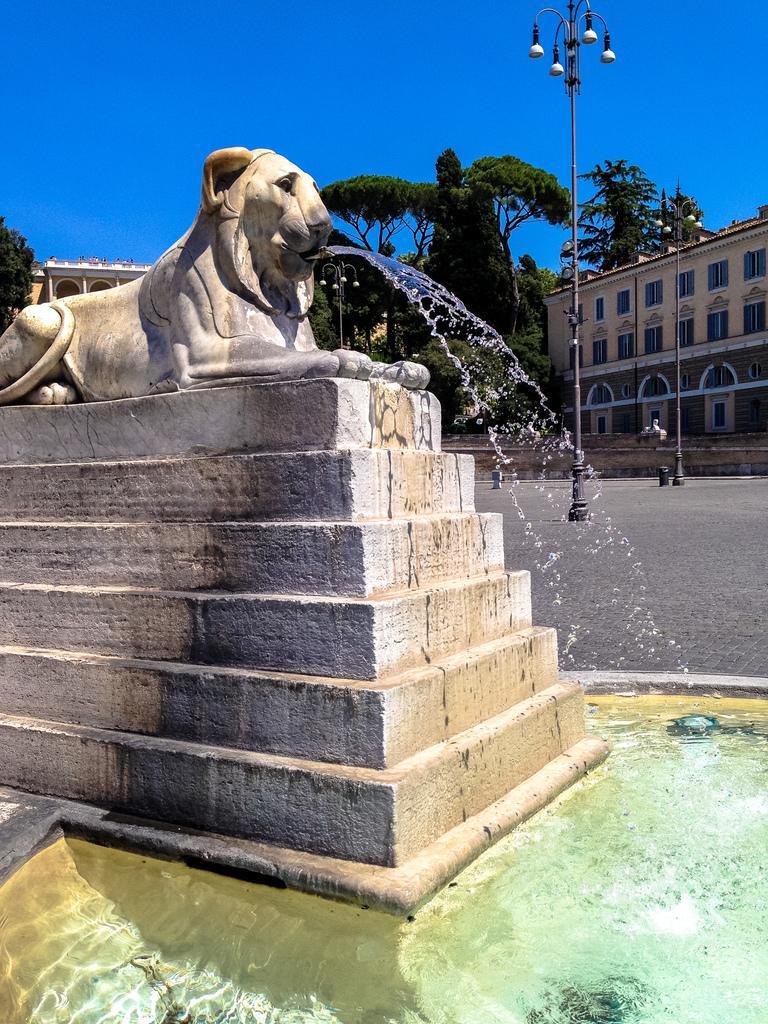How would you summarize this image in a sentence or two? In this image there is a fountain at left side of this image and there is a building at right side of this image and left side of this image and there are some trees in the background and there is a blue sky at top of this image and there are some current polls at right side of this image and there is some water at bottom of this image. 